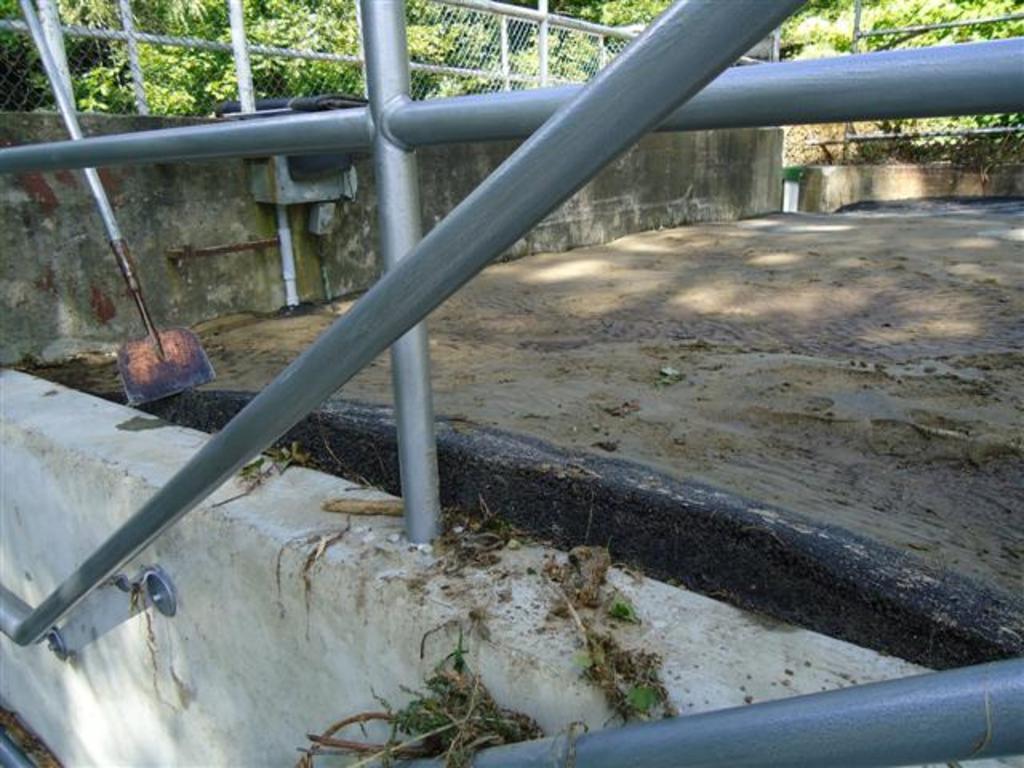Describe this image in one or two sentences. In the image there are metal rods in the front followed by a mud land, behind it there is a shovel on the left side corner inside a fence, in the background there are plants and trees. 